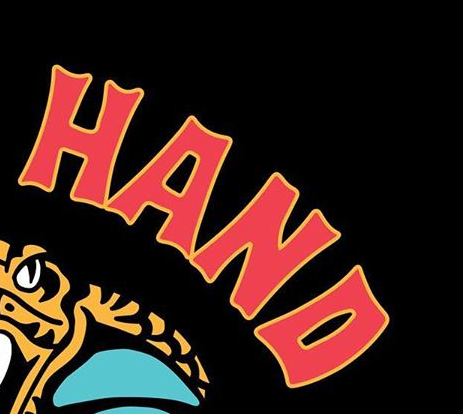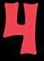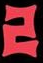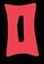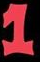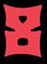What words are shown in these images in order, separated by a semicolon? HAND; 4; 2; 0; 1; 8 